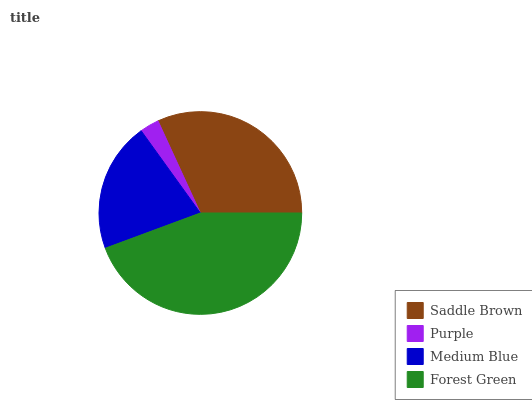Is Purple the minimum?
Answer yes or no. Yes. Is Forest Green the maximum?
Answer yes or no. Yes. Is Medium Blue the minimum?
Answer yes or no. No. Is Medium Blue the maximum?
Answer yes or no. No. Is Medium Blue greater than Purple?
Answer yes or no. Yes. Is Purple less than Medium Blue?
Answer yes or no. Yes. Is Purple greater than Medium Blue?
Answer yes or no. No. Is Medium Blue less than Purple?
Answer yes or no. No. Is Saddle Brown the high median?
Answer yes or no. Yes. Is Medium Blue the low median?
Answer yes or no. Yes. Is Purple the high median?
Answer yes or no. No. Is Forest Green the low median?
Answer yes or no. No. 